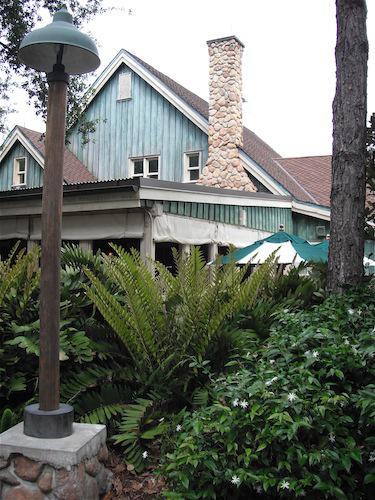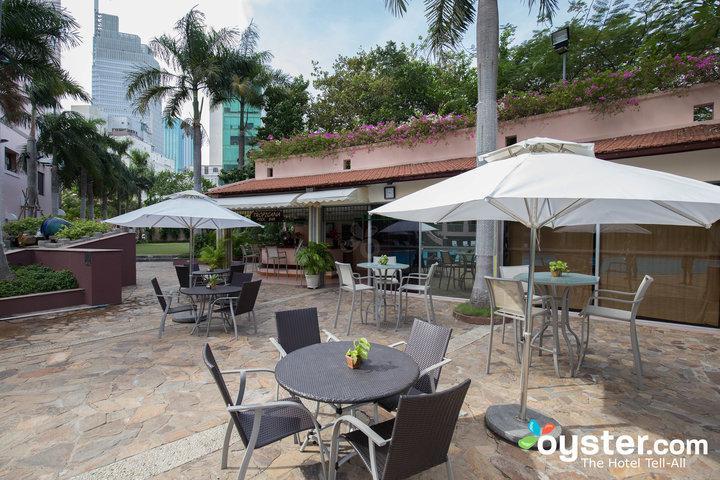The first image is the image on the left, the second image is the image on the right. Given the left and right images, does the statement "In one image, an outdoor seating area in front of a building includes at least two solid-colored patio umbrellas." hold true? Answer yes or no. Yes. The first image is the image on the left, the second image is the image on the right. Examine the images to the left and right. Is the description "There are at most 2 umbrellas in the image on the right." accurate? Answer yes or no. Yes. 